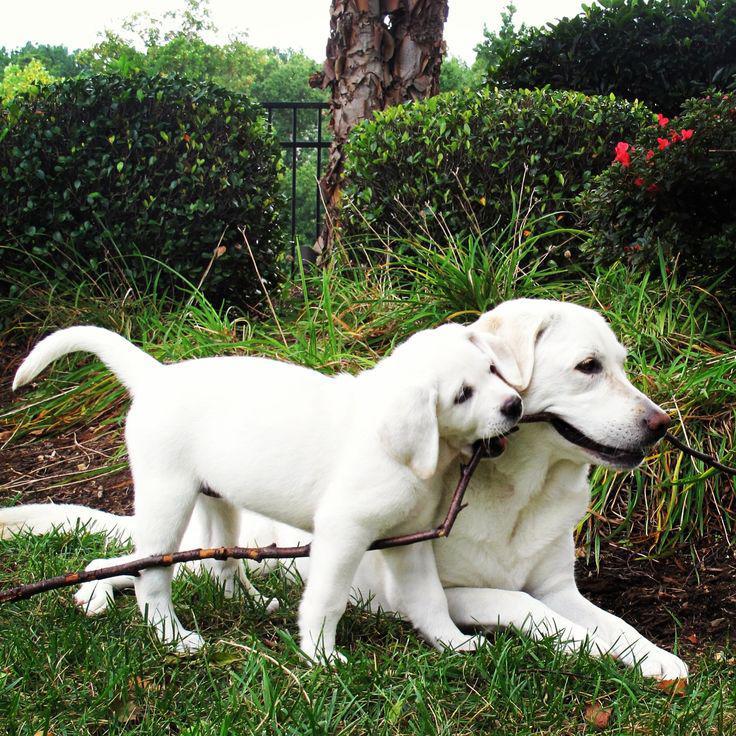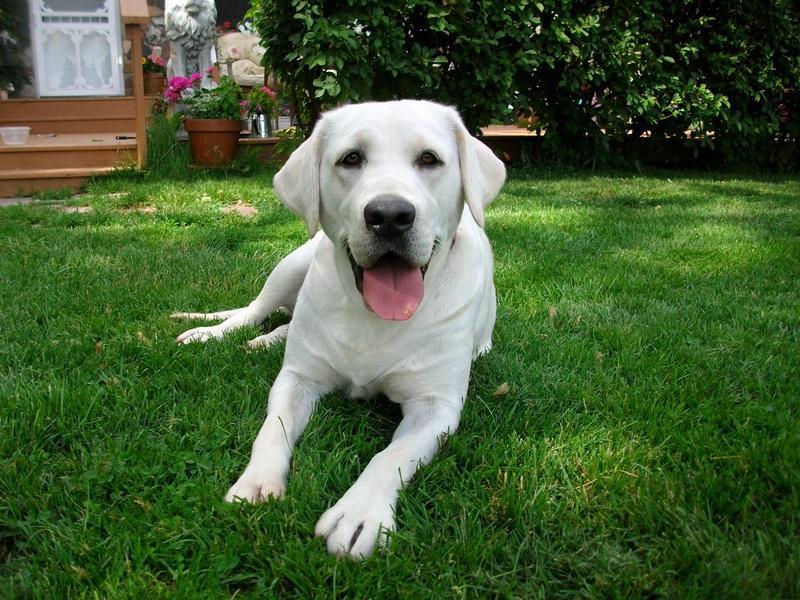The first image is the image on the left, the second image is the image on the right. Considering the images on both sides, is "An image contains exactly two dogs." valid? Answer yes or no. Yes. The first image is the image on the left, the second image is the image on the right. For the images shown, is this caption "There are three dogs in total." true? Answer yes or no. Yes. 